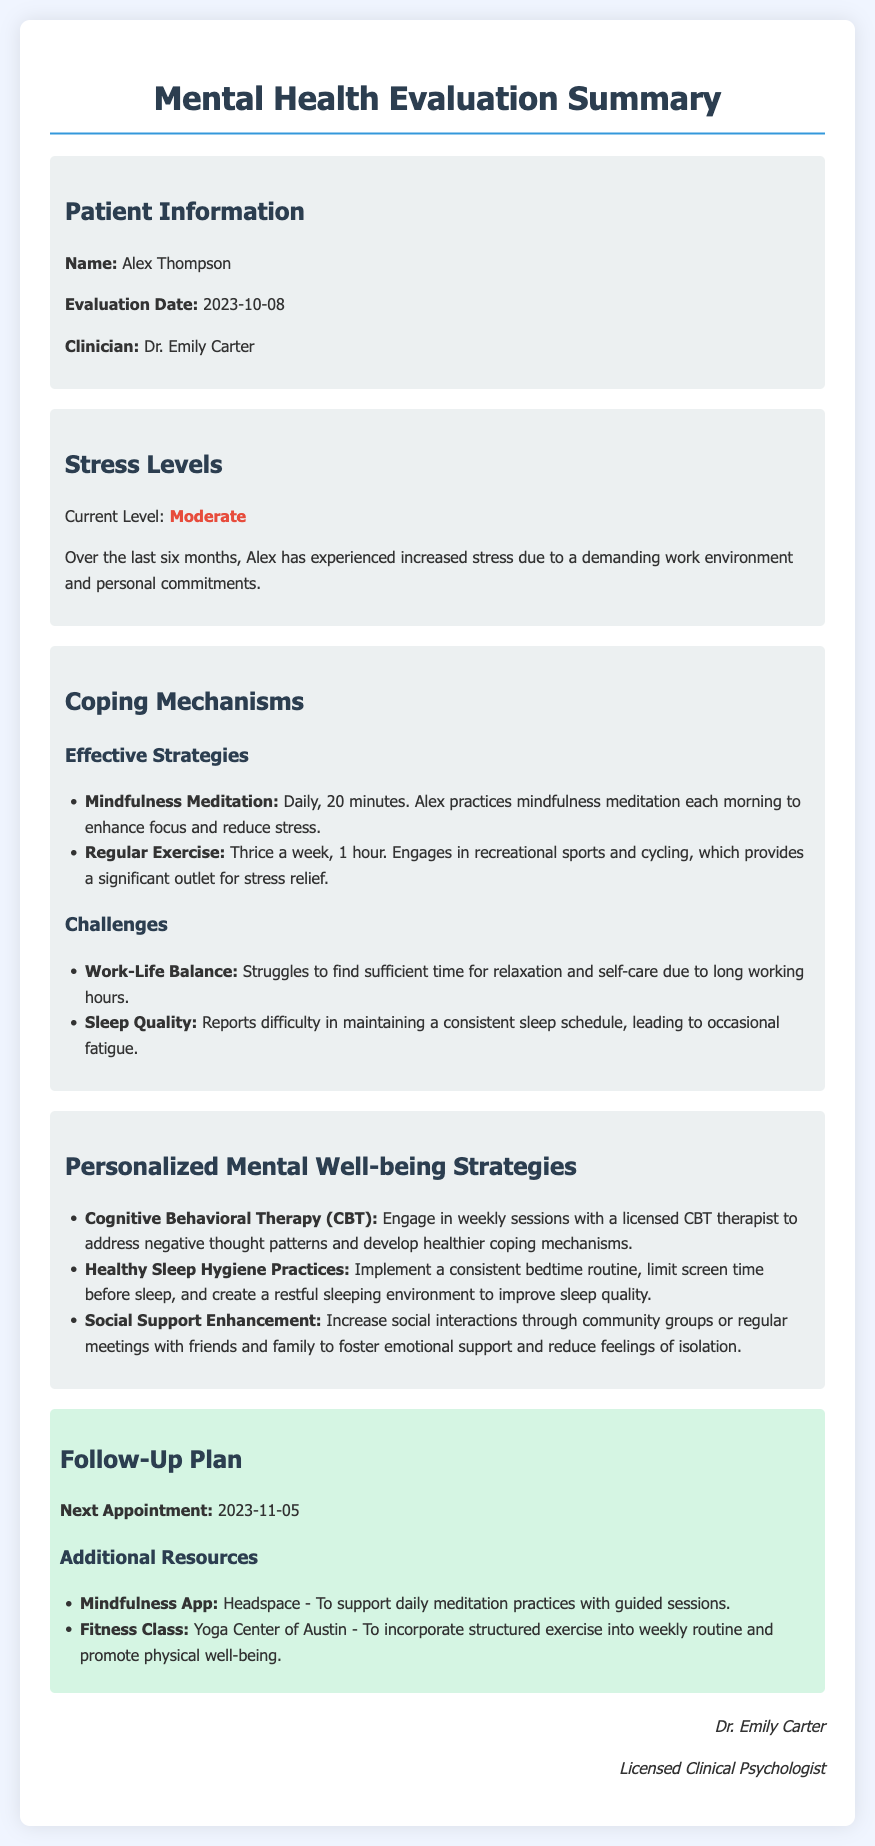What is the patient's name? The patient's name is mentioned in the document under "Patient Information."
Answer: Alex Thompson What is the current level of stress? The current level of stress is mentioned in the "Stress Levels" section.
Answer: Moderate Which coping mechanism involves physical activity? The coping mechanism that involves physical activity is found in the "Effective Strategies" subsection.
Answer: Regular Exercise What issue does Alex face regarding sleep? The issue regarding sleep is detailed in the "Challenges" subsection of "Coping Mechanisms."
Answer: Sleep Quality When is the next appointment scheduled? The date of the next appointment is stated in the "Follow-Up Plan" section.
Answer: 2023-11-05 What therapy is recommended for addressing negative thought patterns? The type of therapy recommended is outlined under "Personalized Mental Well-being Strategies."
Answer: Cognitive Behavioral Therapy (CBT) What mindfulness app is suggested for meditation support? The app recommended for mindfulness practice is mentioned in the "Additional Resources" section.
Answer: Headspace What is a challenge related to work-life balance? The challenge faced in work-life balance is described in the "Challenges" subsection of "Coping Mechanisms."
Answer: Work-Life Balance Who is the clinician that performed the evaluation? The clinician's name is provided in the "Patient Information" section.
Answer: Dr. Emily Carter 